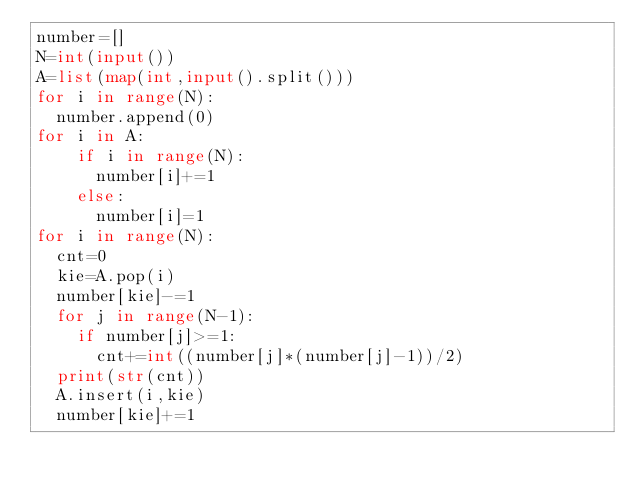<code> <loc_0><loc_0><loc_500><loc_500><_Python_>number=[]
N=int(input())
A=list(map(int,input().split()))
for i in range(N):
  number.append(0)
for i in A:
    if i in range(N):
      number[i]+=1
    else:
      number[i]=1
for i in range(N):
  cnt=0
  kie=A.pop(i)
  number[kie]-=1
  for j in range(N-1):
    if number[j]>=1:
      cnt+=int((number[j]*(number[j]-1))/2)
  print(str(cnt))
  A.insert(i,kie)
  number[kie]+=1</code> 